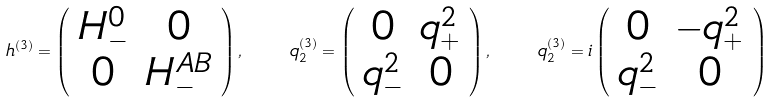<formula> <loc_0><loc_0><loc_500><loc_500>h ^ { ( 3 ) } = \left ( \begin{array} { c c } H _ { - } ^ { 0 } & 0 \\ 0 & H _ { - } ^ { A B } \end{array} \right ) , \quad q ^ { ( 3 ) } _ { 2 } = \left ( \begin{array} { c c } 0 & q _ { + } ^ { 2 } \\ q _ { - } ^ { 2 } & 0 \end{array} \right ) , \quad q ^ { ( 3 ) } _ { 2 } = i \left ( \begin{array} { c c } 0 & - q _ { + } ^ { 2 } \\ q _ { - } ^ { 2 } & 0 \end{array} \right )</formula> 